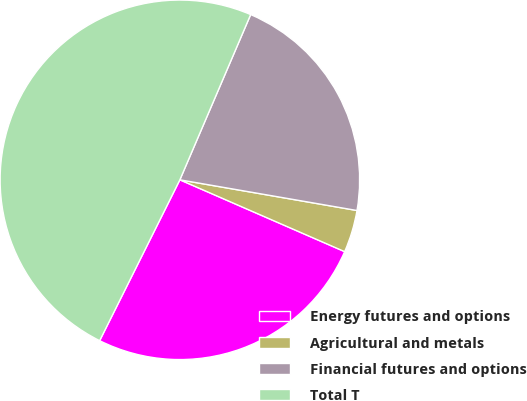Convert chart to OTSL. <chart><loc_0><loc_0><loc_500><loc_500><pie_chart><fcel>Energy futures and options<fcel>Agricultural and metals<fcel>Financial futures and options<fcel>Total T<nl><fcel>25.82%<fcel>3.81%<fcel>21.29%<fcel>49.08%<nl></chart> 